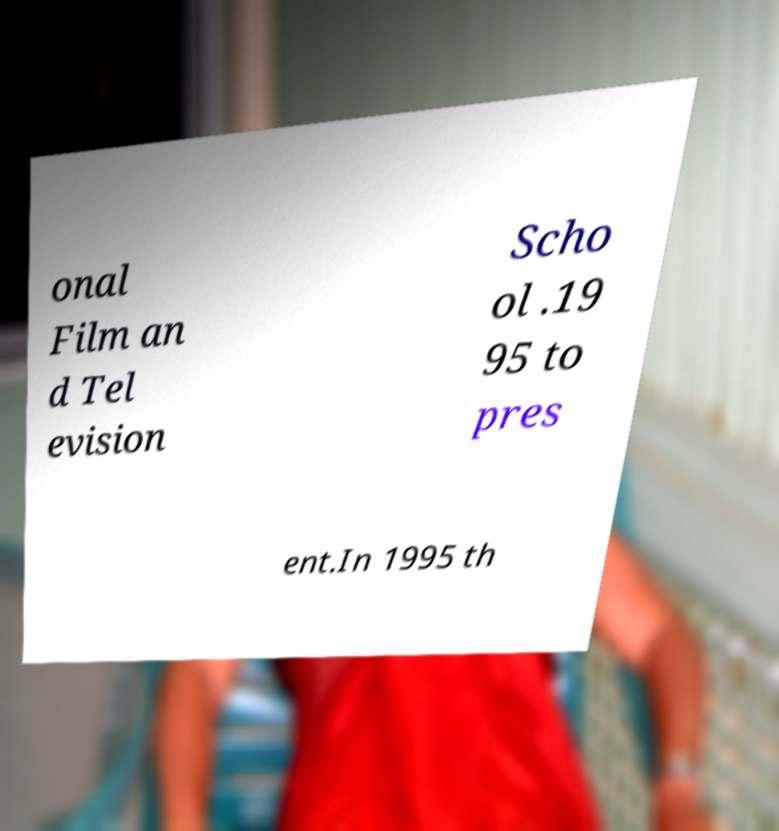Can you accurately transcribe the text from the provided image for me? onal Film an d Tel evision Scho ol .19 95 to pres ent.In 1995 th 